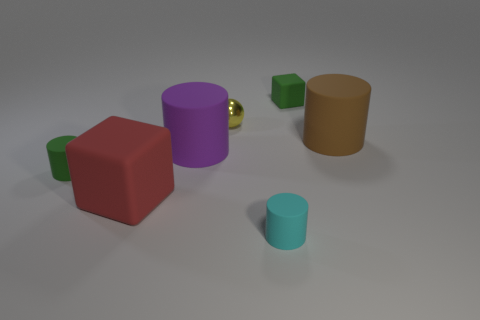Add 1 large gray objects. How many objects exist? 8 Subtract all cubes. How many objects are left? 5 Add 7 large red rubber things. How many large red rubber things are left? 8 Add 7 small gray matte blocks. How many small gray matte blocks exist? 7 Subtract 1 green cylinders. How many objects are left? 6 Subtract all tiny green matte cubes. Subtract all tiny green rubber cubes. How many objects are left? 5 